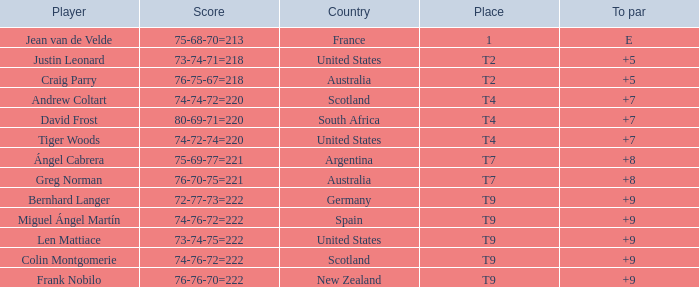For the match in which player David Frost scored a To Par of +7, what was the final score? 80-69-71=220. 